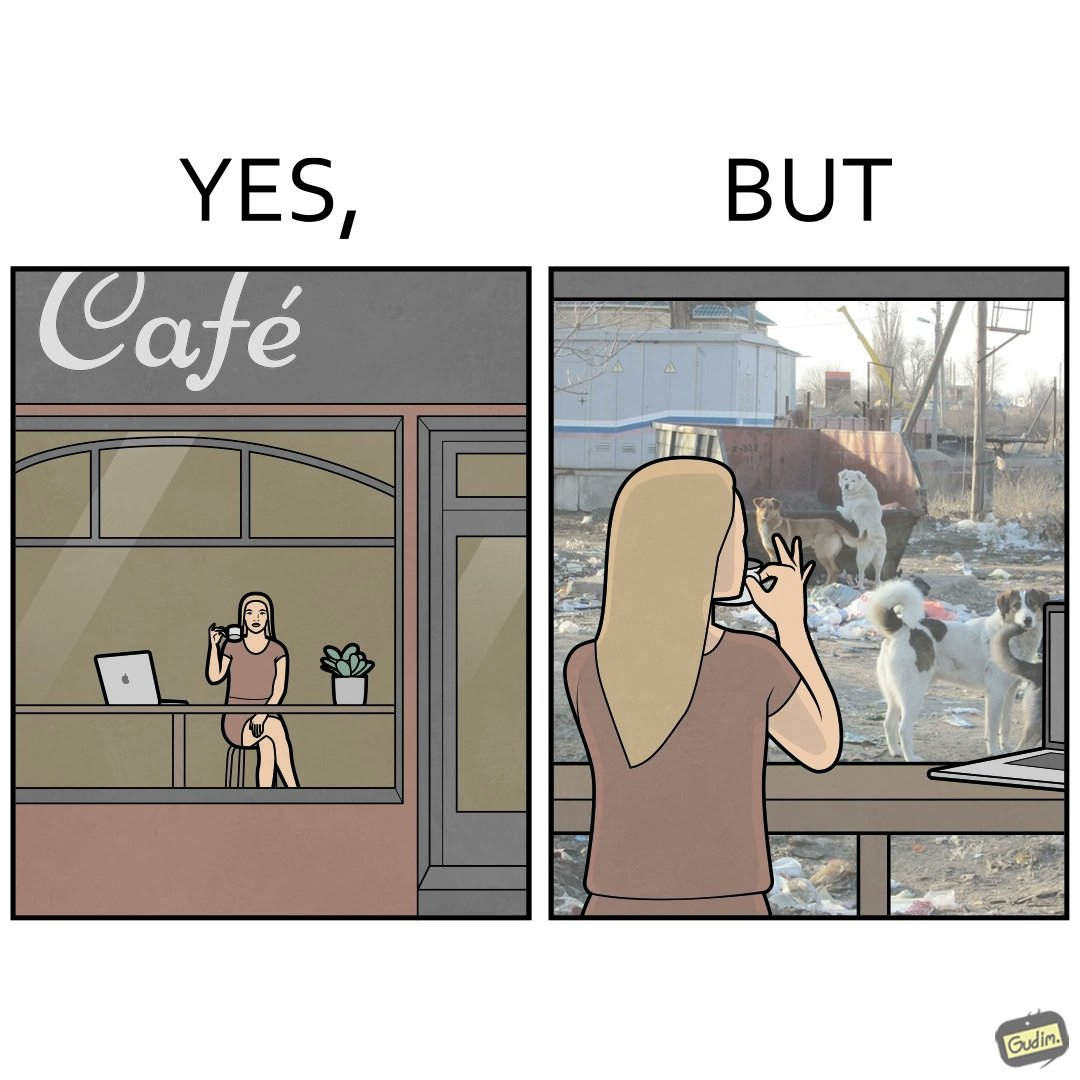Explain the humor or irony in this image. The people nowadays are not concerned about the surroundings, everyone is busy in their life, like in the image it is shown that even when the woman notices the issues faced by stray but even then she is not ready to raise her voice or do some action for the cause 